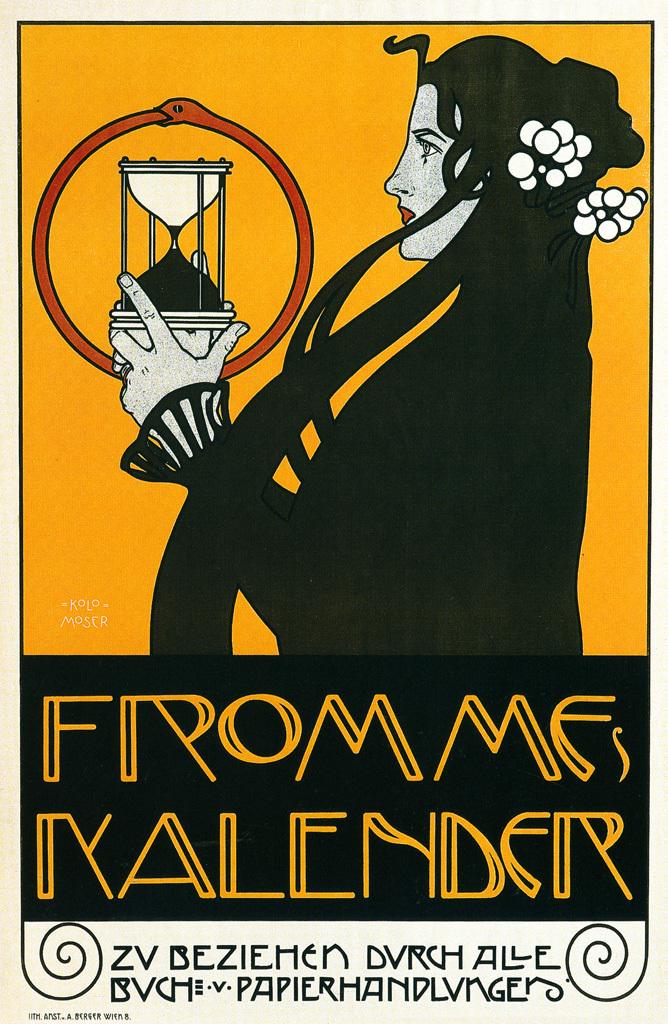What is the title of this?
Make the answer very short. From mfs nalender. 